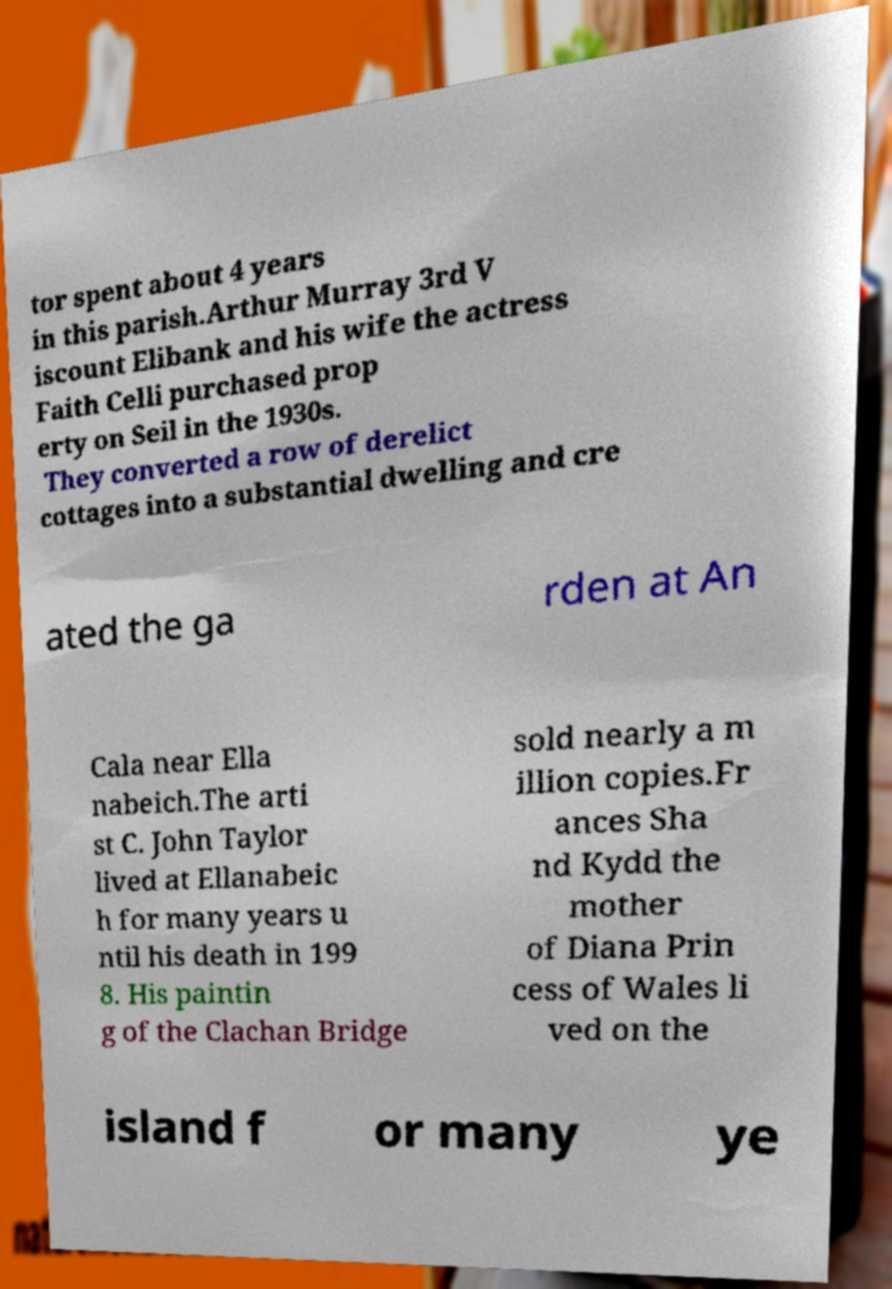What messages or text are displayed in this image? I need them in a readable, typed format. tor spent about 4 years in this parish.Arthur Murray 3rd V iscount Elibank and his wife the actress Faith Celli purchased prop erty on Seil in the 1930s. They converted a row of derelict cottages into a substantial dwelling and cre ated the ga rden at An Cala near Ella nabeich.The arti st C. John Taylor lived at Ellanabeic h for many years u ntil his death in 199 8. His paintin g of the Clachan Bridge sold nearly a m illion copies.Fr ances Sha nd Kydd the mother of Diana Prin cess of Wales li ved on the island f or many ye 